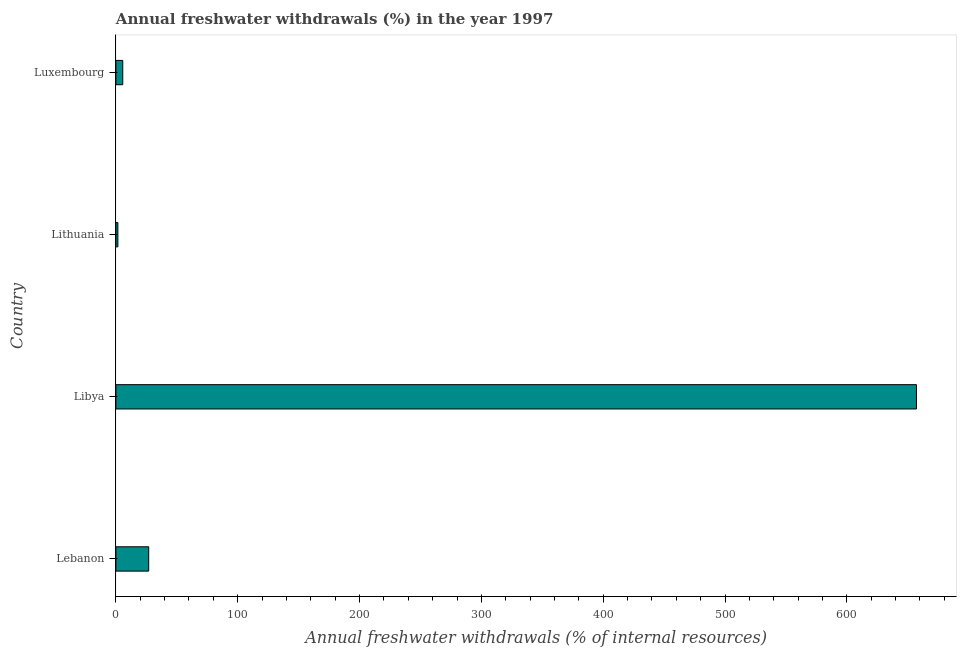Does the graph contain any zero values?
Keep it short and to the point. No. What is the title of the graph?
Make the answer very short. Annual freshwater withdrawals (%) in the year 1997. What is the label or title of the X-axis?
Your answer should be compact. Annual freshwater withdrawals (% of internal resources). What is the label or title of the Y-axis?
Give a very brief answer. Country. What is the annual freshwater withdrawals in Libya?
Give a very brief answer. 657.14. Across all countries, what is the maximum annual freshwater withdrawals?
Offer a terse response. 657.14. Across all countries, what is the minimum annual freshwater withdrawals?
Provide a succinct answer. 1.63. In which country was the annual freshwater withdrawals maximum?
Keep it short and to the point. Libya. In which country was the annual freshwater withdrawals minimum?
Provide a succinct answer. Lithuania. What is the sum of the annual freshwater withdrawals?
Provide a short and direct response. 691.36. What is the difference between the annual freshwater withdrawals in Lebanon and Libya?
Your answer should be very brief. -630.21. What is the average annual freshwater withdrawals per country?
Your response must be concise. 172.84. What is the median annual freshwater withdrawals?
Offer a very short reply. 16.29. In how many countries, is the annual freshwater withdrawals greater than 20 %?
Give a very brief answer. 2. What is the ratio of the annual freshwater withdrawals in Libya to that in Lithuania?
Provide a succinct answer. 404.16. Is the annual freshwater withdrawals in Lithuania less than that in Luxembourg?
Offer a terse response. Yes. Is the difference between the annual freshwater withdrawals in Lebanon and Luxembourg greater than the difference between any two countries?
Make the answer very short. No. What is the difference between the highest and the second highest annual freshwater withdrawals?
Give a very brief answer. 630.21. Is the sum of the annual freshwater withdrawals in Libya and Luxembourg greater than the maximum annual freshwater withdrawals across all countries?
Ensure brevity in your answer.  Yes. What is the difference between the highest and the lowest annual freshwater withdrawals?
Make the answer very short. 655.52. How many countries are there in the graph?
Your answer should be compact. 4. What is the difference between two consecutive major ticks on the X-axis?
Your response must be concise. 100. What is the Annual freshwater withdrawals (% of internal resources) in Lebanon?
Provide a short and direct response. 26.94. What is the Annual freshwater withdrawals (% of internal resources) of Libya?
Your response must be concise. 657.14. What is the Annual freshwater withdrawals (% of internal resources) in Lithuania?
Provide a succinct answer. 1.63. What is the Annual freshwater withdrawals (% of internal resources) of Luxembourg?
Offer a very short reply. 5.65. What is the difference between the Annual freshwater withdrawals (% of internal resources) in Lebanon and Libya?
Offer a very short reply. -630.21. What is the difference between the Annual freshwater withdrawals (% of internal resources) in Lebanon and Lithuania?
Offer a terse response. 25.31. What is the difference between the Annual freshwater withdrawals (% of internal resources) in Lebanon and Luxembourg?
Your answer should be very brief. 21.29. What is the difference between the Annual freshwater withdrawals (% of internal resources) in Libya and Lithuania?
Offer a very short reply. 655.52. What is the difference between the Annual freshwater withdrawals (% of internal resources) in Libya and Luxembourg?
Offer a very short reply. 651.49. What is the difference between the Annual freshwater withdrawals (% of internal resources) in Lithuania and Luxembourg?
Your answer should be very brief. -4.02. What is the ratio of the Annual freshwater withdrawals (% of internal resources) in Lebanon to that in Libya?
Give a very brief answer. 0.04. What is the ratio of the Annual freshwater withdrawals (% of internal resources) in Lebanon to that in Lithuania?
Make the answer very short. 16.57. What is the ratio of the Annual freshwater withdrawals (% of internal resources) in Lebanon to that in Luxembourg?
Give a very brief answer. 4.77. What is the ratio of the Annual freshwater withdrawals (% of internal resources) in Libya to that in Lithuania?
Your answer should be very brief. 404.16. What is the ratio of the Annual freshwater withdrawals (% of internal resources) in Libya to that in Luxembourg?
Your answer should be very brief. 116.31. What is the ratio of the Annual freshwater withdrawals (% of internal resources) in Lithuania to that in Luxembourg?
Offer a terse response. 0.29. 